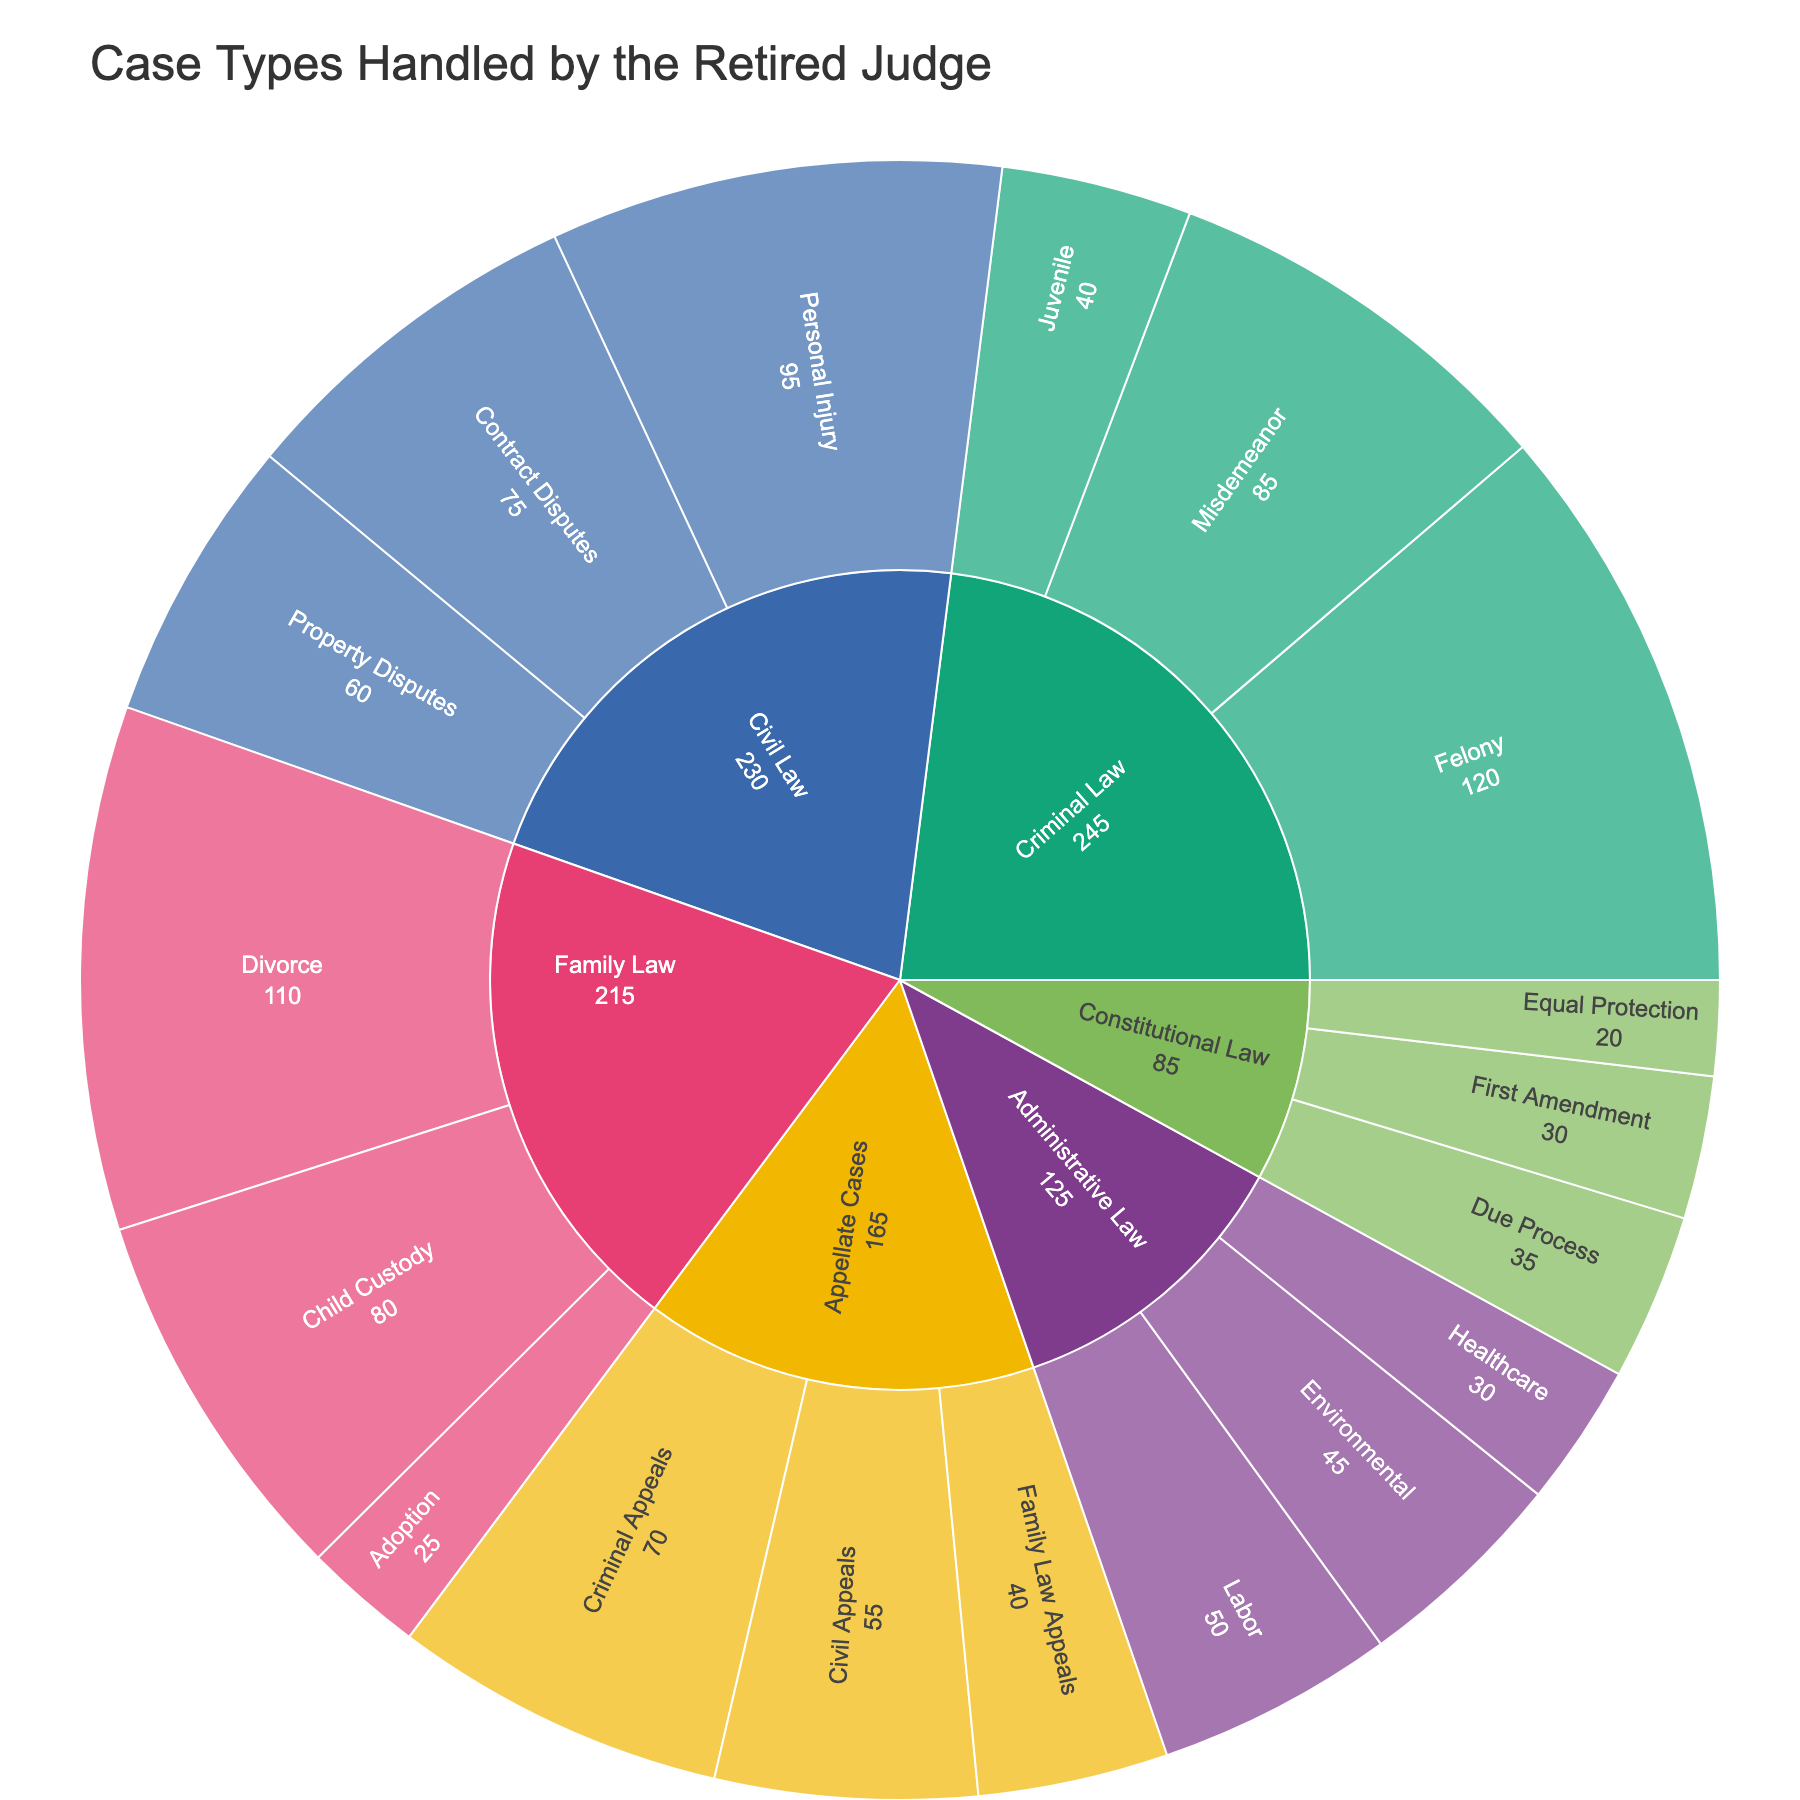What's the title of the plot? The title is displayed at the top of the sunburst plot.
Answer: Case Types Handled by the Retired Judge Which category has the highest number of cases? To determine this, check the outermost ring segments and compare their total counts. Criminal Law has 120 + 85 + 40 = 245 cases. Civil Law has 95 + 75 + 60 = 230 cases. Family Law has 110 + 80 + 25 = 215 cases. Constitutional Law has 30 + 35 + 20 = 85 cases. Administrative Law has 45 + 50 + 30 = 125 cases. Appellate Cases have 70 + 55 + 40 = 165 cases. Criminal Law has the highest total.
Answer: Criminal Law How many cases are there in Family Law? Sum the counts for Divorce (110), Child Custody (80), and Adoption (25). 110 + 80 + 25 = 215
Answer: 215 Which legal domain has the fewest cases? Look at the total cases for each category. Sum by: Criminal Law: 245, Civil Law: 230, Family Law: 215, Constitutional Law: 85, Administrative Law: 125, Appellate Cases: 165. The fewest is Constitutional Law with 85.
Answer: Constitutional Law What is the difference between the number of Felony and Misdemeanor cases? Subtract the count of Misdemeanor (85) from the count of Felony (120). 120 - 85 = 35
Answer: 35 What category does Environmental cases fall under? The Environmental subcategory is within the Administrative Law category as indicated by the structure of the sunburst plot.
Answer: Administrative Law Compare the number of Civil Law cases to Appellate Cases. Which one is higher? Sum the Civil Law cases (95 + 75 + 60 = 230) and Appellate Cases (70 + 55 + 40 = 165). Civil Law has a higher total.
Answer: Civil Law How many cases of Property Disputes and Juvenile combined? Add Property Disputes (60) and Juvenile (40). 60 + 40 = 100
Answer: 100 Which specific type of case has the highest count in the plot? Look at the count for each subcategory in the outer ring. The highest count among all subcategories is Felony with 120 cases.
Answer: Felony 